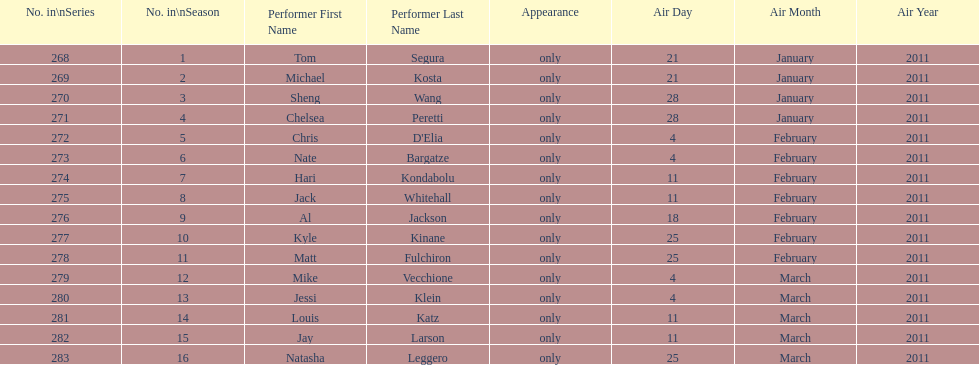How many weeks did season 15 of comedy central presents span? 9. 